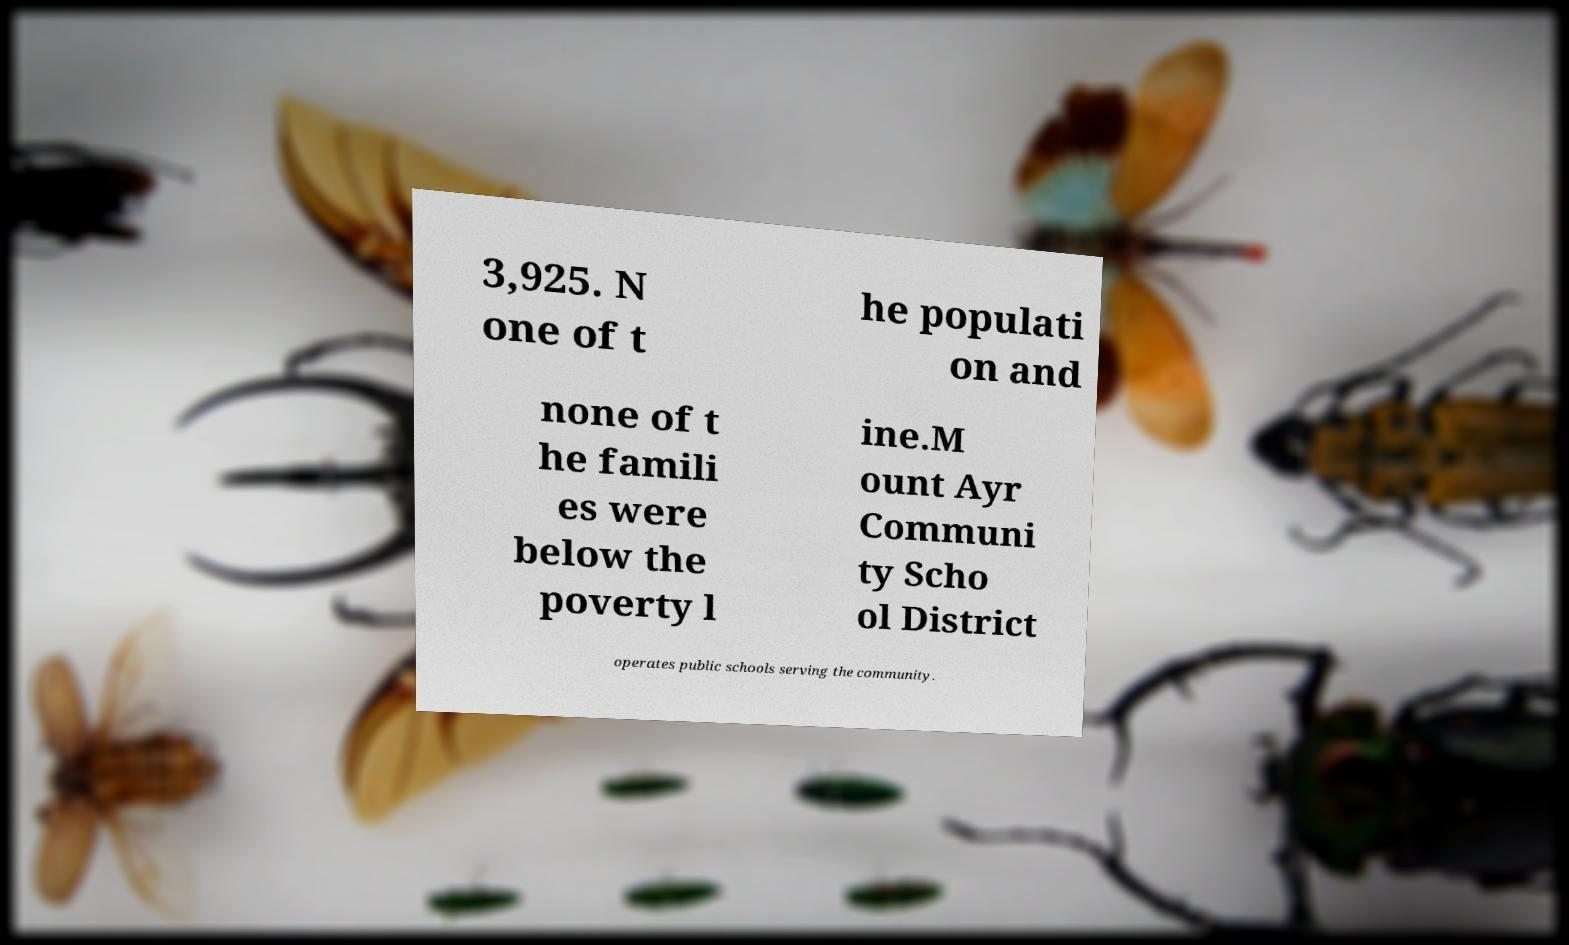There's text embedded in this image that I need extracted. Can you transcribe it verbatim? 3,925. N one of t he populati on and none of t he famili es were below the poverty l ine.M ount Ayr Communi ty Scho ol District operates public schools serving the community. 